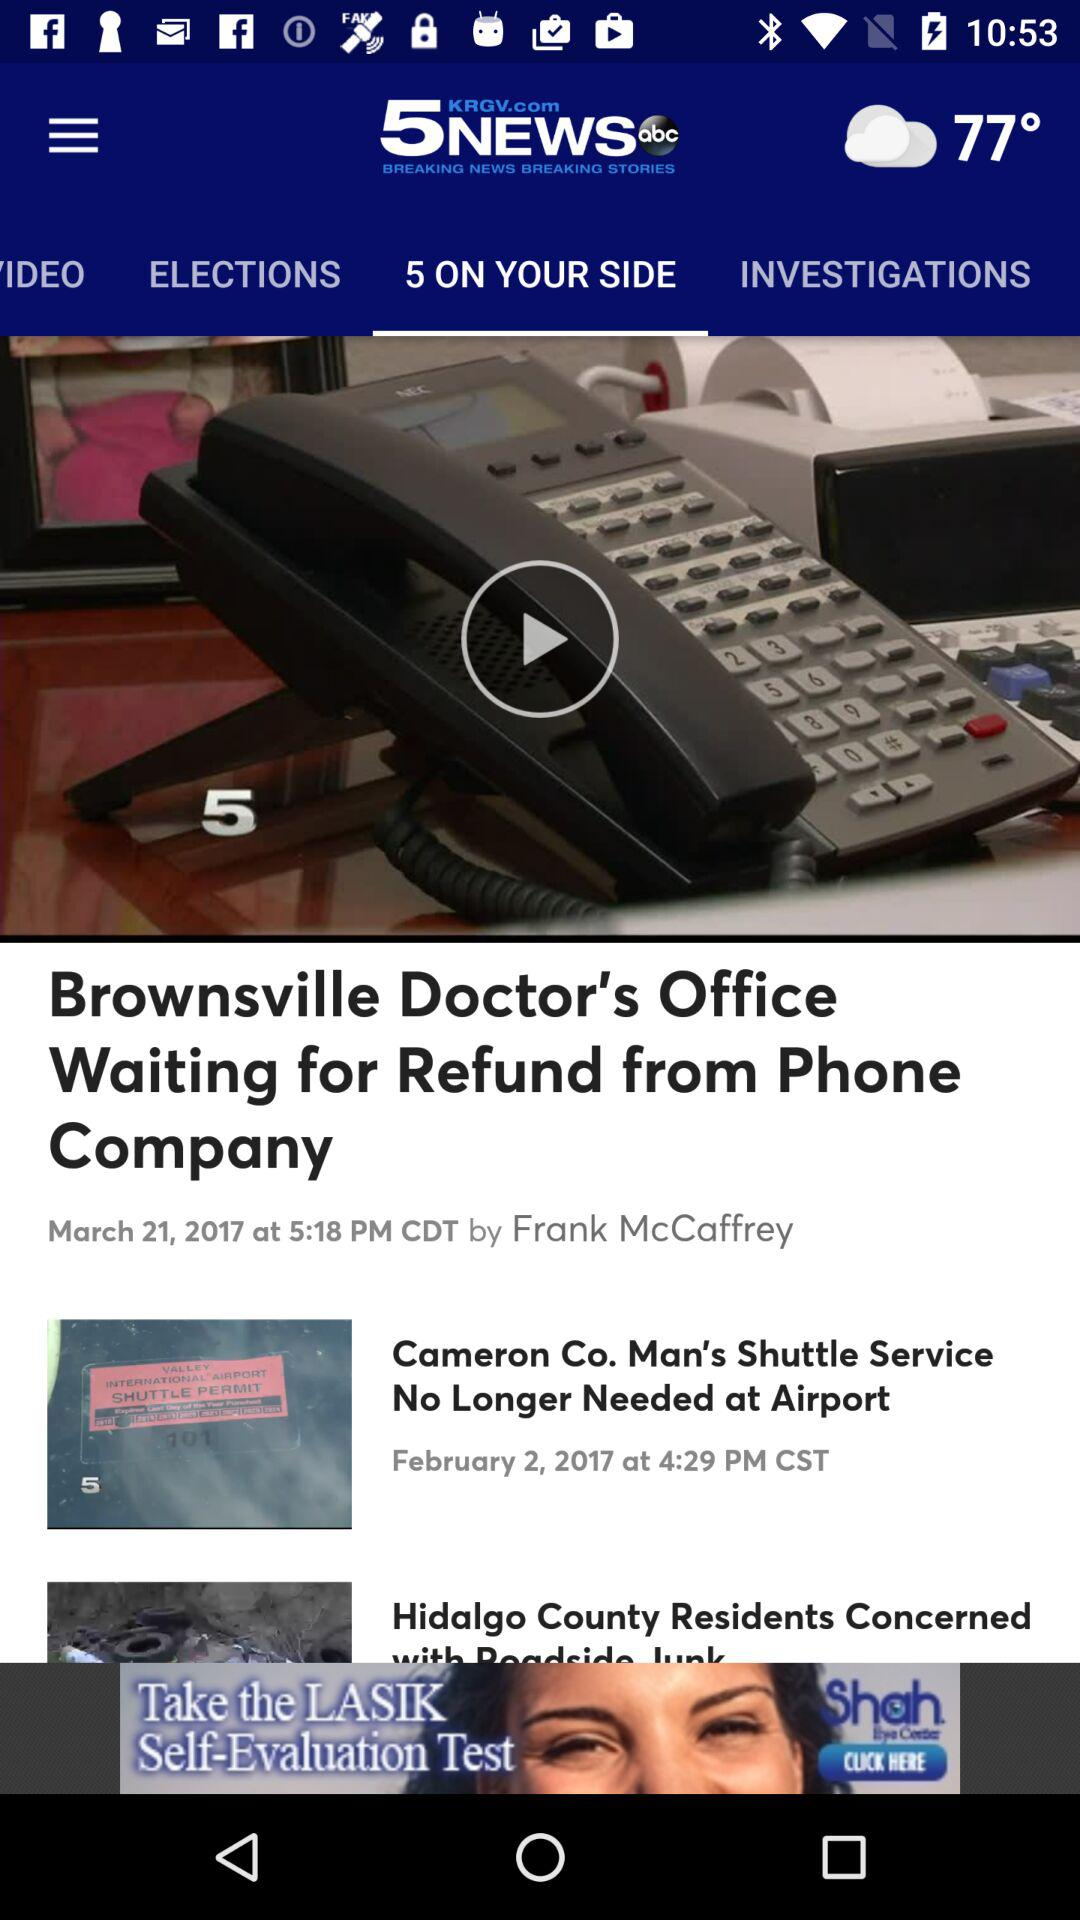When was the news "Cameron Co. Man's Shuttle Service No Longer Needed at Airport" uploaded? The news was uploaded on February 2, 2017 at 4:29 PM. 